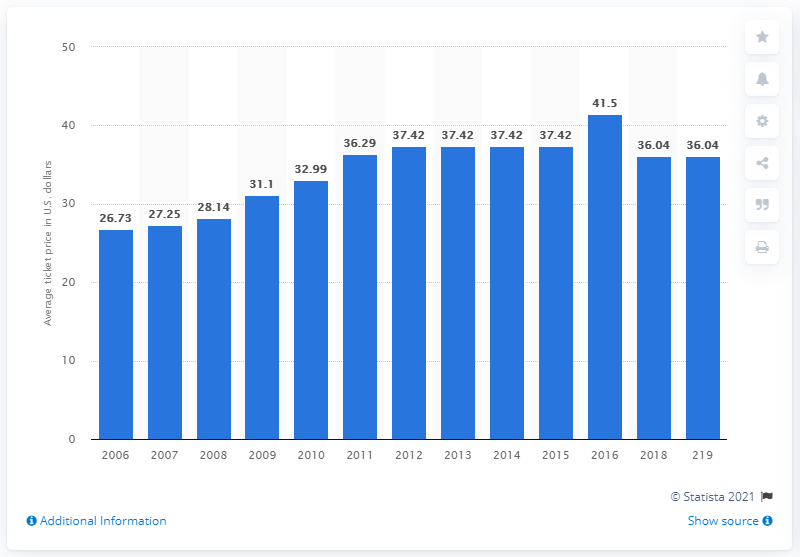Point out several critical features in this image. The average ticket price for Philadelphia Phillies games in 2019 was 36.04 dollars. 